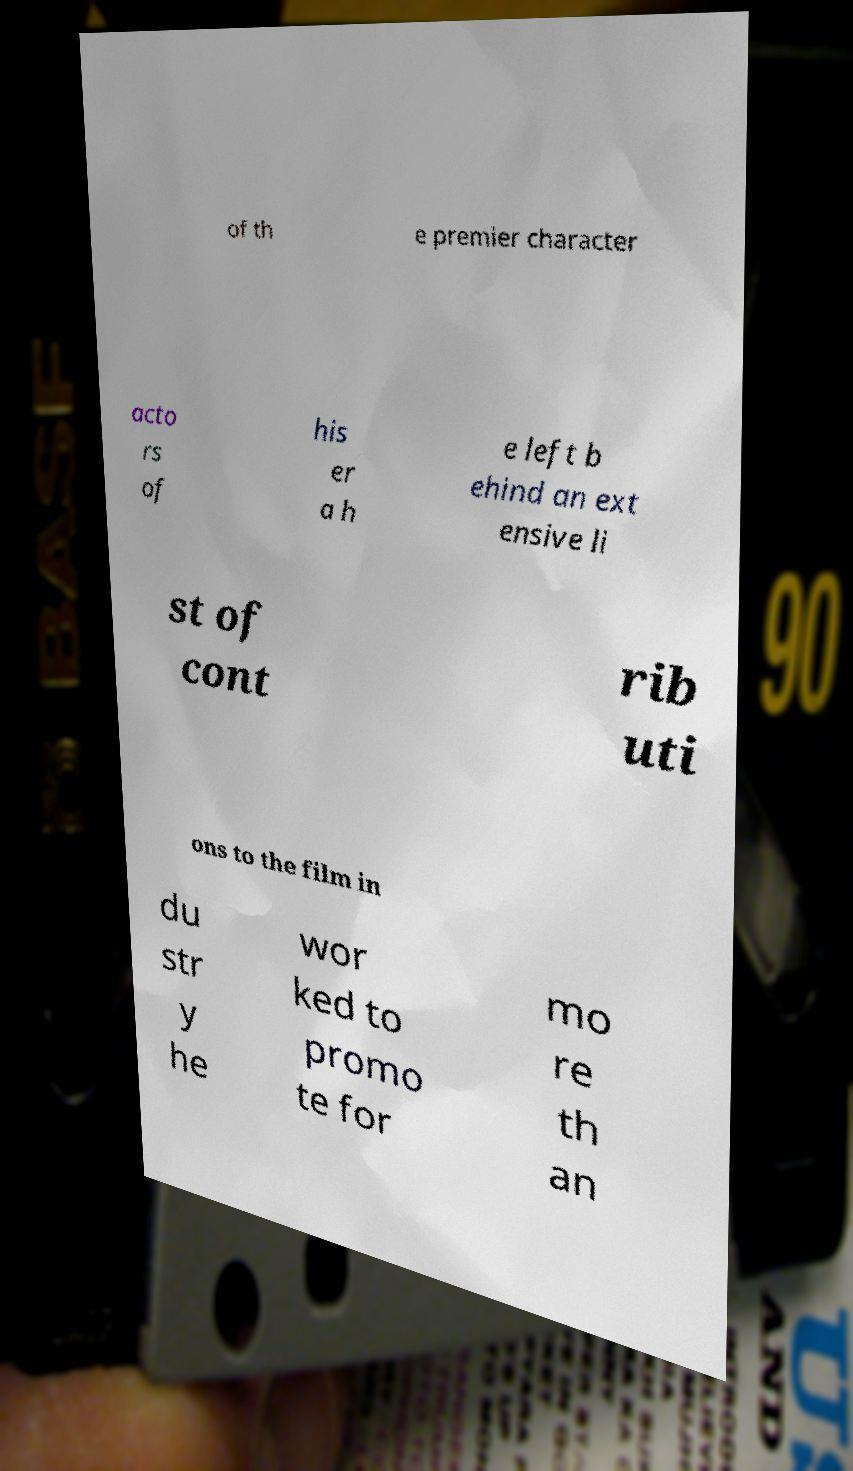There's text embedded in this image that I need extracted. Can you transcribe it verbatim? of th e premier character acto rs of his er a h e left b ehind an ext ensive li st of cont rib uti ons to the film in du str y he wor ked to promo te for mo re th an 